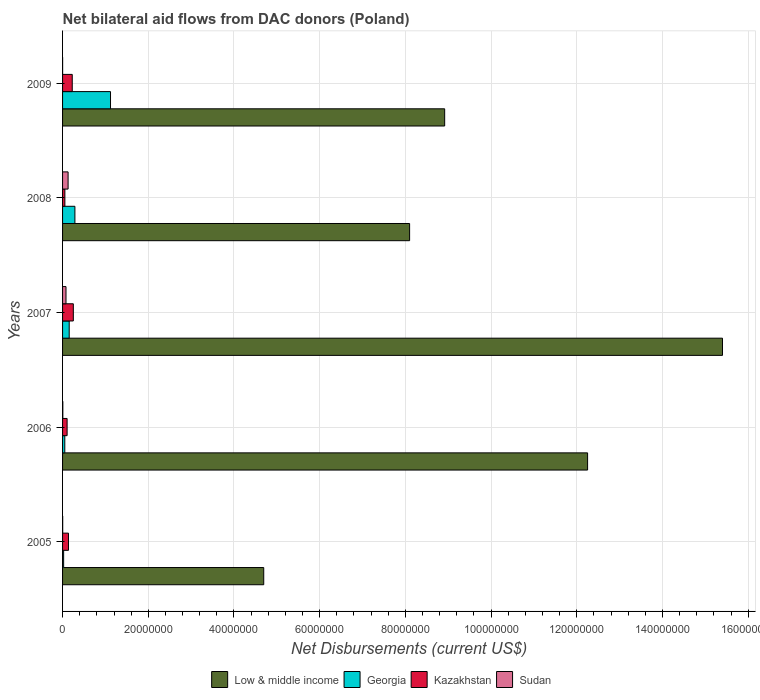How many groups of bars are there?
Offer a terse response. 5. How many bars are there on the 5th tick from the top?
Provide a succinct answer. 4. How many bars are there on the 4th tick from the bottom?
Your answer should be very brief. 4. In how many cases, is the number of bars for a given year not equal to the number of legend labels?
Ensure brevity in your answer.  0. Across all years, what is the maximum net bilateral aid flows in Kazakhstan?
Keep it short and to the point. 2.51e+06. Across all years, what is the minimum net bilateral aid flows in Kazakhstan?
Ensure brevity in your answer.  5.40e+05. In which year was the net bilateral aid flows in Sudan minimum?
Provide a short and direct response. 2009. What is the total net bilateral aid flows in Sudan in the graph?
Offer a terse response. 2.19e+06. What is the difference between the net bilateral aid flows in Sudan in 2006 and that in 2009?
Your answer should be compact. 5.00e+04. What is the difference between the net bilateral aid flows in Low & middle income in 2006 and the net bilateral aid flows in Georgia in 2009?
Offer a very short reply. 1.11e+08. What is the average net bilateral aid flows in Sudan per year?
Ensure brevity in your answer.  4.38e+05. In the year 2008, what is the difference between the net bilateral aid flows in Low & middle income and net bilateral aid flows in Sudan?
Ensure brevity in your answer.  7.97e+07. What is the ratio of the net bilateral aid flows in Sudan in 2007 to that in 2008?
Ensure brevity in your answer.  0.62. What is the difference between the highest and the second highest net bilateral aid flows in Low & middle income?
Offer a terse response. 3.15e+07. What is the difference between the highest and the lowest net bilateral aid flows in Low & middle income?
Offer a very short reply. 1.07e+08. Is the sum of the net bilateral aid flows in Low & middle income in 2005 and 2009 greater than the maximum net bilateral aid flows in Georgia across all years?
Keep it short and to the point. Yes. Is it the case that in every year, the sum of the net bilateral aid flows in Georgia and net bilateral aid flows in Kazakhstan is greater than the sum of net bilateral aid flows in Sudan and net bilateral aid flows in Low & middle income?
Your answer should be very brief. Yes. What does the 1st bar from the top in 2008 represents?
Offer a very short reply. Sudan. What does the 3rd bar from the bottom in 2007 represents?
Your answer should be compact. Kazakhstan. How many bars are there?
Your response must be concise. 20. Are all the bars in the graph horizontal?
Your response must be concise. Yes. Are the values on the major ticks of X-axis written in scientific E-notation?
Your response must be concise. No. Does the graph contain grids?
Keep it short and to the point. Yes. Where does the legend appear in the graph?
Your response must be concise. Bottom center. How many legend labels are there?
Your answer should be compact. 4. What is the title of the graph?
Keep it short and to the point. Net bilateral aid flows from DAC donors (Poland). What is the label or title of the X-axis?
Offer a terse response. Net Disbursements (current US$). What is the Net Disbursements (current US$) of Low & middle income in 2005?
Keep it short and to the point. 4.69e+07. What is the Net Disbursements (current US$) of Georgia in 2005?
Provide a short and direct response. 2.50e+05. What is the Net Disbursements (current US$) of Kazakhstan in 2005?
Your answer should be compact. 1.38e+06. What is the Net Disbursements (current US$) in Low & middle income in 2006?
Offer a very short reply. 1.23e+08. What is the Net Disbursements (current US$) of Georgia in 2006?
Provide a short and direct response. 5.20e+05. What is the Net Disbursements (current US$) of Kazakhstan in 2006?
Give a very brief answer. 1.06e+06. What is the Net Disbursements (current US$) in Low & middle income in 2007?
Offer a terse response. 1.54e+08. What is the Net Disbursements (current US$) of Georgia in 2007?
Provide a succinct answer. 1.55e+06. What is the Net Disbursements (current US$) in Kazakhstan in 2007?
Your answer should be compact. 2.51e+06. What is the Net Disbursements (current US$) in Sudan in 2007?
Provide a short and direct response. 8.00e+05. What is the Net Disbursements (current US$) in Low & middle income in 2008?
Your answer should be very brief. 8.10e+07. What is the Net Disbursements (current US$) in Georgia in 2008?
Ensure brevity in your answer.  2.88e+06. What is the Net Disbursements (current US$) in Kazakhstan in 2008?
Provide a succinct answer. 5.40e+05. What is the Net Disbursements (current US$) of Sudan in 2008?
Give a very brief answer. 1.29e+06. What is the Net Disbursements (current US$) of Low & middle income in 2009?
Offer a terse response. 8.92e+07. What is the Net Disbursements (current US$) in Georgia in 2009?
Offer a terse response. 1.12e+07. What is the Net Disbursements (current US$) of Kazakhstan in 2009?
Your response must be concise. 2.26e+06. Across all years, what is the maximum Net Disbursements (current US$) in Low & middle income?
Provide a succinct answer. 1.54e+08. Across all years, what is the maximum Net Disbursements (current US$) in Georgia?
Make the answer very short. 1.12e+07. Across all years, what is the maximum Net Disbursements (current US$) in Kazakhstan?
Offer a very short reply. 2.51e+06. Across all years, what is the maximum Net Disbursements (current US$) in Sudan?
Give a very brief answer. 1.29e+06. Across all years, what is the minimum Net Disbursements (current US$) in Low & middle income?
Provide a short and direct response. 4.69e+07. Across all years, what is the minimum Net Disbursements (current US$) in Georgia?
Your answer should be very brief. 2.50e+05. Across all years, what is the minimum Net Disbursements (current US$) of Kazakhstan?
Provide a succinct answer. 5.40e+05. What is the total Net Disbursements (current US$) of Low & middle income in the graph?
Offer a terse response. 4.94e+08. What is the total Net Disbursements (current US$) in Georgia in the graph?
Ensure brevity in your answer.  1.64e+07. What is the total Net Disbursements (current US$) in Kazakhstan in the graph?
Keep it short and to the point. 7.75e+06. What is the total Net Disbursements (current US$) of Sudan in the graph?
Ensure brevity in your answer.  2.19e+06. What is the difference between the Net Disbursements (current US$) in Low & middle income in 2005 and that in 2006?
Offer a very short reply. -7.56e+07. What is the difference between the Net Disbursements (current US$) in Georgia in 2005 and that in 2006?
Your answer should be very brief. -2.70e+05. What is the difference between the Net Disbursements (current US$) of Kazakhstan in 2005 and that in 2006?
Offer a very short reply. 3.20e+05. What is the difference between the Net Disbursements (current US$) of Sudan in 2005 and that in 2006?
Provide a short and direct response. -3.00e+04. What is the difference between the Net Disbursements (current US$) in Low & middle income in 2005 and that in 2007?
Make the answer very short. -1.07e+08. What is the difference between the Net Disbursements (current US$) in Georgia in 2005 and that in 2007?
Keep it short and to the point. -1.30e+06. What is the difference between the Net Disbursements (current US$) of Kazakhstan in 2005 and that in 2007?
Your answer should be very brief. -1.13e+06. What is the difference between the Net Disbursements (current US$) of Sudan in 2005 and that in 2007?
Offer a very short reply. -7.70e+05. What is the difference between the Net Disbursements (current US$) in Low & middle income in 2005 and that in 2008?
Ensure brevity in your answer.  -3.40e+07. What is the difference between the Net Disbursements (current US$) in Georgia in 2005 and that in 2008?
Provide a succinct answer. -2.63e+06. What is the difference between the Net Disbursements (current US$) of Kazakhstan in 2005 and that in 2008?
Your answer should be compact. 8.40e+05. What is the difference between the Net Disbursements (current US$) of Sudan in 2005 and that in 2008?
Make the answer very short. -1.26e+06. What is the difference between the Net Disbursements (current US$) in Low & middle income in 2005 and that in 2009?
Your answer should be compact. -4.22e+07. What is the difference between the Net Disbursements (current US$) in Georgia in 2005 and that in 2009?
Offer a terse response. -1.09e+07. What is the difference between the Net Disbursements (current US$) of Kazakhstan in 2005 and that in 2009?
Give a very brief answer. -8.80e+05. What is the difference between the Net Disbursements (current US$) of Sudan in 2005 and that in 2009?
Keep it short and to the point. 2.00e+04. What is the difference between the Net Disbursements (current US$) of Low & middle income in 2006 and that in 2007?
Keep it short and to the point. -3.15e+07. What is the difference between the Net Disbursements (current US$) of Georgia in 2006 and that in 2007?
Offer a terse response. -1.03e+06. What is the difference between the Net Disbursements (current US$) of Kazakhstan in 2006 and that in 2007?
Offer a very short reply. -1.45e+06. What is the difference between the Net Disbursements (current US$) in Sudan in 2006 and that in 2007?
Offer a terse response. -7.40e+05. What is the difference between the Net Disbursements (current US$) in Low & middle income in 2006 and that in 2008?
Provide a short and direct response. 4.15e+07. What is the difference between the Net Disbursements (current US$) of Georgia in 2006 and that in 2008?
Keep it short and to the point. -2.36e+06. What is the difference between the Net Disbursements (current US$) in Kazakhstan in 2006 and that in 2008?
Ensure brevity in your answer.  5.20e+05. What is the difference between the Net Disbursements (current US$) in Sudan in 2006 and that in 2008?
Your answer should be very brief. -1.23e+06. What is the difference between the Net Disbursements (current US$) of Low & middle income in 2006 and that in 2009?
Give a very brief answer. 3.34e+07. What is the difference between the Net Disbursements (current US$) in Georgia in 2006 and that in 2009?
Provide a succinct answer. -1.07e+07. What is the difference between the Net Disbursements (current US$) of Kazakhstan in 2006 and that in 2009?
Your response must be concise. -1.20e+06. What is the difference between the Net Disbursements (current US$) in Low & middle income in 2007 and that in 2008?
Your response must be concise. 7.30e+07. What is the difference between the Net Disbursements (current US$) of Georgia in 2007 and that in 2008?
Keep it short and to the point. -1.33e+06. What is the difference between the Net Disbursements (current US$) in Kazakhstan in 2007 and that in 2008?
Give a very brief answer. 1.97e+06. What is the difference between the Net Disbursements (current US$) in Sudan in 2007 and that in 2008?
Offer a terse response. -4.90e+05. What is the difference between the Net Disbursements (current US$) of Low & middle income in 2007 and that in 2009?
Your response must be concise. 6.48e+07. What is the difference between the Net Disbursements (current US$) in Georgia in 2007 and that in 2009?
Your answer should be compact. -9.64e+06. What is the difference between the Net Disbursements (current US$) in Kazakhstan in 2007 and that in 2009?
Make the answer very short. 2.50e+05. What is the difference between the Net Disbursements (current US$) of Sudan in 2007 and that in 2009?
Offer a terse response. 7.90e+05. What is the difference between the Net Disbursements (current US$) in Low & middle income in 2008 and that in 2009?
Make the answer very short. -8.18e+06. What is the difference between the Net Disbursements (current US$) in Georgia in 2008 and that in 2009?
Make the answer very short. -8.31e+06. What is the difference between the Net Disbursements (current US$) in Kazakhstan in 2008 and that in 2009?
Offer a very short reply. -1.72e+06. What is the difference between the Net Disbursements (current US$) in Sudan in 2008 and that in 2009?
Provide a short and direct response. 1.28e+06. What is the difference between the Net Disbursements (current US$) of Low & middle income in 2005 and the Net Disbursements (current US$) of Georgia in 2006?
Keep it short and to the point. 4.64e+07. What is the difference between the Net Disbursements (current US$) of Low & middle income in 2005 and the Net Disbursements (current US$) of Kazakhstan in 2006?
Make the answer very short. 4.59e+07. What is the difference between the Net Disbursements (current US$) in Low & middle income in 2005 and the Net Disbursements (current US$) in Sudan in 2006?
Offer a terse response. 4.69e+07. What is the difference between the Net Disbursements (current US$) in Georgia in 2005 and the Net Disbursements (current US$) in Kazakhstan in 2006?
Your answer should be very brief. -8.10e+05. What is the difference between the Net Disbursements (current US$) of Georgia in 2005 and the Net Disbursements (current US$) of Sudan in 2006?
Your response must be concise. 1.90e+05. What is the difference between the Net Disbursements (current US$) of Kazakhstan in 2005 and the Net Disbursements (current US$) of Sudan in 2006?
Your response must be concise. 1.32e+06. What is the difference between the Net Disbursements (current US$) in Low & middle income in 2005 and the Net Disbursements (current US$) in Georgia in 2007?
Your answer should be very brief. 4.54e+07. What is the difference between the Net Disbursements (current US$) in Low & middle income in 2005 and the Net Disbursements (current US$) in Kazakhstan in 2007?
Provide a succinct answer. 4.44e+07. What is the difference between the Net Disbursements (current US$) of Low & middle income in 2005 and the Net Disbursements (current US$) of Sudan in 2007?
Provide a short and direct response. 4.61e+07. What is the difference between the Net Disbursements (current US$) of Georgia in 2005 and the Net Disbursements (current US$) of Kazakhstan in 2007?
Your answer should be very brief. -2.26e+06. What is the difference between the Net Disbursements (current US$) in Georgia in 2005 and the Net Disbursements (current US$) in Sudan in 2007?
Keep it short and to the point. -5.50e+05. What is the difference between the Net Disbursements (current US$) in Kazakhstan in 2005 and the Net Disbursements (current US$) in Sudan in 2007?
Provide a short and direct response. 5.80e+05. What is the difference between the Net Disbursements (current US$) in Low & middle income in 2005 and the Net Disbursements (current US$) in Georgia in 2008?
Offer a very short reply. 4.41e+07. What is the difference between the Net Disbursements (current US$) in Low & middle income in 2005 and the Net Disbursements (current US$) in Kazakhstan in 2008?
Offer a terse response. 4.64e+07. What is the difference between the Net Disbursements (current US$) of Low & middle income in 2005 and the Net Disbursements (current US$) of Sudan in 2008?
Provide a short and direct response. 4.56e+07. What is the difference between the Net Disbursements (current US$) of Georgia in 2005 and the Net Disbursements (current US$) of Sudan in 2008?
Your answer should be compact. -1.04e+06. What is the difference between the Net Disbursements (current US$) in Kazakhstan in 2005 and the Net Disbursements (current US$) in Sudan in 2008?
Keep it short and to the point. 9.00e+04. What is the difference between the Net Disbursements (current US$) of Low & middle income in 2005 and the Net Disbursements (current US$) of Georgia in 2009?
Ensure brevity in your answer.  3.58e+07. What is the difference between the Net Disbursements (current US$) of Low & middle income in 2005 and the Net Disbursements (current US$) of Kazakhstan in 2009?
Your answer should be very brief. 4.47e+07. What is the difference between the Net Disbursements (current US$) in Low & middle income in 2005 and the Net Disbursements (current US$) in Sudan in 2009?
Your answer should be very brief. 4.69e+07. What is the difference between the Net Disbursements (current US$) of Georgia in 2005 and the Net Disbursements (current US$) of Kazakhstan in 2009?
Your answer should be very brief. -2.01e+06. What is the difference between the Net Disbursements (current US$) in Kazakhstan in 2005 and the Net Disbursements (current US$) in Sudan in 2009?
Make the answer very short. 1.37e+06. What is the difference between the Net Disbursements (current US$) of Low & middle income in 2006 and the Net Disbursements (current US$) of Georgia in 2007?
Ensure brevity in your answer.  1.21e+08. What is the difference between the Net Disbursements (current US$) in Low & middle income in 2006 and the Net Disbursements (current US$) in Kazakhstan in 2007?
Offer a very short reply. 1.20e+08. What is the difference between the Net Disbursements (current US$) in Low & middle income in 2006 and the Net Disbursements (current US$) in Sudan in 2007?
Make the answer very short. 1.22e+08. What is the difference between the Net Disbursements (current US$) of Georgia in 2006 and the Net Disbursements (current US$) of Kazakhstan in 2007?
Your response must be concise. -1.99e+06. What is the difference between the Net Disbursements (current US$) in Georgia in 2006 and the Net Disbursements (current US$) in Sudan in 2007?
Your answer should be compact. -2.80e+05. What is the difference between the Net Disbursements (current US$) in Kazakhstan in 2006 and the Net Disbursements (current US$) in Sudan in 2007?
Keep it short and to the point. 2.60e+05. What is the difference between the Net Disbursements (current US$) in Low & middle income in 2006 and the Net Disbursements (current US$) in Georgia in 2008?
Give a very brief answer. 1.20e+08. What is the difference between the Net Disbursements (current US$) of Low & middle income in 2006 and the Net Disbursements (current US$) of Kazakhstan in 2008?
Your response must be concise. 1.22e+08. What is the difference between the Net Disbursements (current US$) of Low & middle income in 2006 and the Net Disbursements (current US$) of Sudan in 2008?
Offer a terse response. 1.21e+08. What is the difference between the Net Disbursements (current US$) of Georgia in 2006 and the Net Disbursements (current US$) of Sudan in 2008?
Offer a very short reply. -7.70e+05. What is the difference between the Net Disbursements (current US$) in Low & middle income in 2006 and the Net Disbursements (current US$) in Georgia in 2009?
Provide a short and direct response. 1.11e+08. What is the difference between the Net Disbursements (current US$) of Low & middle income in 2006 and the Net Disbursements (current US$) of Kazakhstan in 2009?
Offer a terse response. 1.20e+08. What is the difference between the Net Disbursements (current US$) in Low & middle income in 2006 and the Net Disbursements (current US$) in Sudan in 2009?
Keep it short and to the point. 1.22e+08. What is the difference between the Net Disbursements (current US$) of Georgia in 2006 and the Net Disbursements (current US$) of Kazakhstan in 2009?
Provide a succinct answer. -1.74e+06. What is the difference between the Net Disbursements (current US$) of Georgia in 2006 and the Net Disbursements (current US$) of Sudan in 2009?
Offer a terse response. 5.10e+05. What is the difference between the Net Disbursements (current US$) in Kazakhstan in 2006 and the Net Disbursements (current US$) in Sudan in 2009?
Provide a short and direct response. 1.05e+06. What is the difference between the Net Disbursements (current US$) of Low & middle income in 2007 and the Net Disbursements (current US$) of Georgia in 2008?
Your answer should be very brief. 1.51e+08. What is the difference between the Net Disbursements (current US$) in Low & middle income in 2007 and the Net Disbursements (current US$) in Kazakhstan in 2008?
Offer a terse response. 1.53e+08. What is the difference between the Net Disbursements (current US$) in Low & middle income in 2007 and the Net Disbursements (current US$) in Sudan in 2008?
Your answer should be compact. 1.53e+08. What is the difference between the Net Disbursements (current US$) in Georgia in 2007 and the Net Disbursements (current US$) in Kazakhstan in 2008?
Provide a succinct answer. 1.01e+06. What is the difference between the Net Disbursements (current US$) in Georgia in 2007 and the Net Disbursements (current US$) in Sudan in 2008?
Your answer should be very brief. 2.60e+05. What is the difference between the Net Disbursements (current US$) of Kazakhstan in 2007 and the Net Disbursements (current US$) of Sudan in 2008?
Keep it short and to the point. 1.22e+06. What is the difference between the Net Disbursements (current US$) in Low & middle income in 2007 and the Net Disbursements (current US$) in Georgia in 2009?
Provide a short and direct response. 1.43e+08. What is the difference between the Net Disbursements (current US$) in Low & middle income in 2007 and the Net Disbursements (current US$) in Kazakhstan in 2009?
Offer a terse response. 1.52e+08. What is the difference between the Net Disbursements (current US$) of Low & middle income in 2007 and the Net Disbursements (current US$) of Sudan in 2009?
Offer a terse response. 1.54e+08. What is the difference between the Net Disbursements (current US$) of Georgia in 2007 and the Net Disbursements (current US$) of Kazakhstan in 2009?
Ensure brevity in your answer.  -7.10e+05. What is the difference between the Net Disbursements (current US$) in Georgia in 2007 and the Net Disbursements (current US$) in Sudan in 2009?
Provide a succinct answer. 1.54e+06. What is the difference between the Net Disbursements (current US$) of Kazakhstan in 2007 and the Net Disbursements (current US$) of Sudan in 2009?
Provide a short and direct response. 2.50e+06. What is the difference between the Net Disbursements (current US$) in Low & middle income in 2008 and the Net Disbursements (current US$) in Georgia in 2009?
Your answer should be very brief. 6.98e+07. What is the difference between the Net Disbursements (current US$) of Low & middle income in 2008 and the Net Disbursements (current US$) of Kazakhstan in 2009?
Make the answer very short. 7.87e+07. What is the difference between the Net Disbursements (current US$) of Low & middle income in 2008 and the Net Disbursements (current US$) of Sudan in 2009?
Offer a very short reply. 8.10e+07. What is the difference between the Net Disbursements (current US$) of Georgia in 2008 and the Net Disbursements (current US$) of Kazakhstan in 2009?
Your answer should be very brief. 6.20e+05. What is the difference between the Net Disbursements (current US$) of Georgia in 2008 and the Net Disbursements (current US$) of Sudan in 2009?
Your answer should be compact. 2.87e+06. What is the difference between the Net Disbursements (current US$) in Kazakhstan in 2008 and the Net Disbursements (current US$) in Sudan in 2009?
Your response must be concise. 5.30e+05. What is the average Net Disbursements (current US$) in Low & middle income per year?
Keep it short and to the point. 9.87e+07. What is the average Net Disbursements (current US$) in Georgia per year?
Your response must be concise. 3.28e+06. What is the average Net Disbursements (current US$) of Kazakhstan per year?
Your answer should be compact. 1.55e+06. What is the average Net Disbursements (current US$) in Sudan per year?
Your answer should be compact. 4.38e+05. In the year 2005, what is the difference between the Net Disbursements (current US$) of Low & middle income and Net Disbursements (current US$) of Georgia?
Your answer should be compact. 4.67e+07. In the year 2005, what is the difference between the Net Disbursements (current US$) in Low & middle income and Net Disbursements (current US$) in Kazakhstan?
Your answer should be very brief. 4.56e+07. In the year 2005, what is the difference between the Net Disbursements (current US$) in Low & middle income and Net Disbursements (current US$) in Sudan?
Your answer should be very brief. 4.69e+07. In the year 2005, what is the difference between the Net Disbursements (current US$) of Georgia and Net Disbursements (current US$) of Kazakhstan?
Make the answer very short. -1.13e+06. In the year 2005, what is the difference between the Net Disbursements (current US$) of Kazakhstan and Net Disbursements (current US$) of Sudan?
Ensure brevity in your answer.  1.35e+06. In the year 2006, what is the difference between the Net Disbursements (current US$) in Low & middle income and Net Disbursements (current US$) in Georgia?
Your answer should be very brief. 1.22e+08. In the year 2006, what is the difference between the Net Disbursements (current US$) of Low & middle income and Net Disbursements (current US$) of Kazakhstan?
Your response must be concise. 1.21e+08. In the year 2006, what is the difference between the Net Disbursements (current US$) of Low & middle income and Net Disbursements (current US$) of Sudan?
Ensure brevity in your answer.  1.22e+08. In the year 2006, what is the difference between the Net Disbursements (current US$) in Georgia and Net Disbursements (current US$) in Kazakhstan?
Provide a succinct answer. -5.40e+05. In the year 2007, what is the difference between the Net Disbursements (current US$) in Low & middle income and Net Disbursements (current US$) in Georgia?
Your answer should be compact. 1.52e+08. In the year 2007, what is the difference between the Net Disbursements (current US$) of Low & middle income and Net Disbursements (current US$) of Kazakhstan?
Your answer should be very brief. 1.51e+08. In the year 2007, what is the difference between the Net Disbursements (current US$) in Low & middle income and Net Disbursements (current US$) in Sudan?
Your response must be concise. 1.53e+08. In the year 2007, what is the difference between the Net Disbursements (current US$) of Georgia and Net Disbursements (current US$) of Kazakhstan?
Keep it short and to the point. -9.60e+05. In the year 2007, what is the difference between the Net Disbursements (current US$) of Georgia and Net Disbursements (current US$) of Sudan?
Make the answer very short. 7.50e+05. In the year 2007, what is the difference between the Net Disbursements (current US$) of Kazakhstan and Net Disbursements (current US$) of Sudan?
Ensure brevity in your answer.  1.71e+06. In the year 2008, what is the difference between the Net Disbursements (current US$) in Low & middle income and Net Disbursements (current US$) in Georgia?
Your response must be concise. 7.81e+07. In the year 2008, what is the difference between the Net Disbursements (current US$) of Low & middle income and Net Disbursements (current US$) of Kazakhstan?
Your response must be concise. 8.04e+07. In the year 2008, what is the difference between the Net Disbursements (current US$) in Low & middle income and Net Disbursements (current US$) in Sudan?
Your answer should be very brief. 7.97e+07. In the year 2008, what is the difference between the Net Disbursements (current US$) in Georgia and Net Disbursements (current US$) in Kazakhstan?
Provide a short and direct response. 2.34e+06. In the year 2008, what is the difference between the Net Disbursements (current US$) in Georgia and Net Disbursements (current US$) in Sudan?
Offer a terse response. 1.59e+06. In the year 2008, what is the difference between the Net Disbursements (current US$) of Kazakhstan and Net Disbursements (current US$) of Sudan?
Ensure brevity in your answer.  -7.50e+05. In the year 2009, what is the difference between the Net Disbursements (current US$) of Low & middle income and Net Disbursements (current US$) of Georgia?
Provide a short and direct response. 7.80e+07. In the year 2009, what is the difference between the Net Disbursements (current US$) of Low & middle income and Net Disbursements (current US$) of Kazakhstan?
Provide a succinct answer. 8.69e+07. In the year 2009, what is the difference between the Net Disbursements (current US$) of Low & middle income and Net Disbursements (current US$) of Sudan?
Ensure brevity in your answer.  8.92e+07. In the year 2009, what is the difference between the Net Disbursements (current US$) in Georgia and Net Disbursements (current US$) in Kazakhstan?
Your answer should be very brief. 8.93e+06. In the year 2009, what is the difference between the Net Disbursements (current US$) in Georgia and Net Disbursements (current US$) in Sudan?
Provide a short and direct response. 1.12e+07. In the year 2009, what is the difference between the Net Disbursements (current US$) in Kazakhstan and Net Disbursements (current US$) in Sudan?
Provide a succinct answer. 2.25e+06. What is the ratio of the Net Disbursements (current US$) of Low & middle income in 2005 to that in 2006?
Keep it short and to the point. 0.38. What is the ratio of the Net Disbursements (current US$) of Georgia in 2005 to that in 2006?
Give a very brief answer. 0.48. What is the ratio of the Net Disbursements (current US$) in Kazakhstan in 2005 to that in 2006?
Provide a short and direct response. 1.3. What is the ratio of the Net Disbursements (current US$) of Sudan in 2005 to that in 2006?
Your response must be concise. 0.5. What is the ratio of the Net Disbursements (current US$) of Low & middle income in 2005 to that in 2007?
Provide a short and direct response. 0.3. What is the ratio of the Net Disbursements (current US$) in Georgia in 2005 to that in 2007?
Offer a very short reply. 0.16. What is the ratio of the Net Disbursements (current US$) of Kazakhstan in 2005 to that in 2007?
Your response must be concise. 0.55. What is the ratio of the Net Disbursements (current US$) in Sudan in 2005 to that in 2007?
Provide a succinct answer. 0.04. What is the ratio of the Net Disbursements (current US$) of Low & middle income in 2005 to that in 2008?
Give a very brief answer. 0.58. What is the ratio of the Net Disbursements (current US$) in Georgia in 2005 to that in 2008?
Make the answer very short. 0.09. What is the ratio of the Net Disbursements (current US$) in Kazakhstan in 2005 to that in 2008?
Provide a short and direct response. 2.56. What is the ratio of the Net Disbursements (current US$) of Sudan in 2005 to that in 2008?
Provide a succinct answer. 0.02. What is the ratio of the Net Disbursements (current US$) in Low & middle income in 2005 to that in 2009?
Your answer should be compact. 0.53. What is the ratio of the Net Disbursements (current US$) of Georgia in 2005 to that in 2009?
Your answer should be very brief. 0.02. What is the ratio of the Net Disbursements (current US$) in Kazakhstan in 2005 to that in 2009?
Ensure brevity in your answer.  0.61. What is the ratio of the Net Disbursements (current US$) of Sudan in 2005 to that in 2009?
Offer a very short reply. 3. What is the ratio of the Net Disbursements (current US$) of Low & middle income in 2006 to that in 2007?
Provide a succinct answer. 0.8. What is the ratio of the Net Disbursements (current US$) in Georgia in 2006 to that in 2007?
Ensure brevity in your answer.  0.34. What is the ratio of the Net Disbursements (current US$) of Kazakhstan in 2006 to that in 2007?
Offer a terse response. 0.42. What is the ratio of the Net Disbursements (current US$) in Sudan in 2006 to that in 2007?
Your answer should be very brief. 0.07. What is the ratio of the Net Disbursements (current US$) in Low & middle income in 2006 to that in 2008?
Keep it short and to the point. 1.51. What is the ratio of the Net Disbursements (current US$) in Georgia in 2006 to that in 2008?
Make the answer very short. 0.18. What is the ratio of the Net Disbursements (current US$) of Kazakhstan in 2006 to that in 2008?
Your answer should be compact. 1.96. What is the ratio of the Net Disbursements (current US$) of Sudan in 2006 to that in 2008?
Keep it short and to the point. 0.05. What is the ratio of the Net Disbursements (current US$) of Low & middle income in 2006 to that in 2009?
Provide a short and direct response. 1.37. What is the ratio of the Net Disbursements (current US$) in Georgia in 2006 to that in 2009?
Your answer should be very brief. 0.05. What is the ratio of the Net Disbursements (current US$) of Kazakhstan in 2006 to that in 2009?
Provide a succinct answer. 0.47. What is the ratio of the Net Disbursements (current US$) of Low & middle income in 2007 to that in 2008?
Your answer should be compact. 1.9. What is the ratio of the Net Disbursements (current US$) of Georgia in 2007 to that in 2008?
Give a very brief answer. 0.54. What is the ratio of the Net Disbursements (current US$) of Kazakhstan in 2007 to that in 2008?
Make the answer very short. 4.65. What is the ratio of the Net Disbursements (current US$) of Sudan in 2007 to that in 2008?
Provide a succinct answer. 0.62. What is the ratio of the Net Disbursements (current US$) of Low & middle income in 2007 to that in 2009?
Provide a succinct answer. 1.73. What is the ratio of the Net Disbursements (current US$) of Georgia in 2007 to that in 2009?
Your answer should be very brief. 0.14. What is the ratio of the Net Disbursements (current US$) of Kazakhstan in 2007 to that in 2009?
Give a very brief answer. 1.11. What is the ratio of the Net Disbursements (current US$) of Sudan in 2007 to that in 2009?
Ensure brevity in your answer.  80. What is the ratio of the Net Disbursements (current US$) in Low & middle income in 2008 to that in 2009?
Keep it short and to the point. 0.91. What is the ratio of the Net Disbursements (current US$) of Georgia in 2008 to that in 2009?
Offer a terse response. 0.26. What is the ratio of the Net Disbursements (current US$) of Kazakhstan in 2008 to that in 2009?
Offer a terse response. 0.24. What is the ratio of the Net Disbursements (current US$) of Sudan in 2008 to that in 2009?
Offer a terse response. 129. What is the difference between the highest and the second highest Net Disbursements (current US$) of Low & middle income?
Your response must be concise. 3.15e+07. What is the difference between the highest and the second highest Net Disbursements (current US$) in Georgia?
Your answer should be compact. 8.31e+06. What is the difference between the highest and the second highest Net Disbursements (current US$) in Sudan?
Your response must be concise. 4.90e+05. What is the difference between the highest and the lowest Net Disbursements (current US$) in Low & middle income?
Give a very brief answer. 1.07e+08. What is the difference between the highest and the lowest Net Disbursements (current US$) in Georgia?
Make the answer very short. 1.09e+07. What is the difference between the highest and the lowest Net Disbursements (current US$) of Kazakhstan?
Provide a short and direct response. 1.97e+06. What is the difference between the highest and the lowest Net Disbursements (current US$) in Sudan?
Your answer should be very brief. 1.28e+06. 